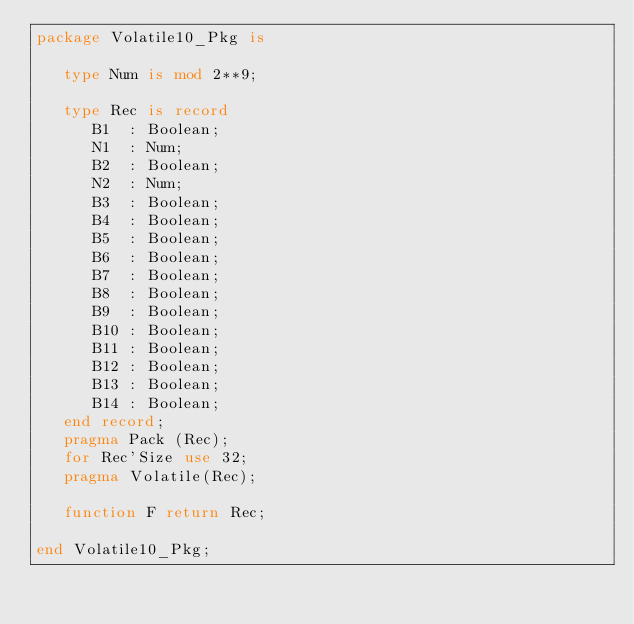<code> <loc_0><loc_0><loc_500><loc_500><_Ada_>package Volatile10_Pkg is

   type Num is mod 2**9;

   type Rec is record
      B1  : Boolean;
      N1  : Num;
      B2  : Boolean;
      N2  : Num;
      B3  : Boolean;
      B4  : Boolean;
      B5  : Boolean;
      B6  : Boolean;
      B7  : Boolean;
      B8  : Boolean;
      B9  : Boolean;
      B10 : Boolean;
      B11 : Boolean;
      B12 : Boolean;
      B13 : Boolean;
      B14 : Boolean;
   end record;
   pragma Pack (Rec);
   for Rec'Size use 32;
   pragma Volatile(Rec);

   function F return Rec;

end Volatile10_Pkg;
</code> 